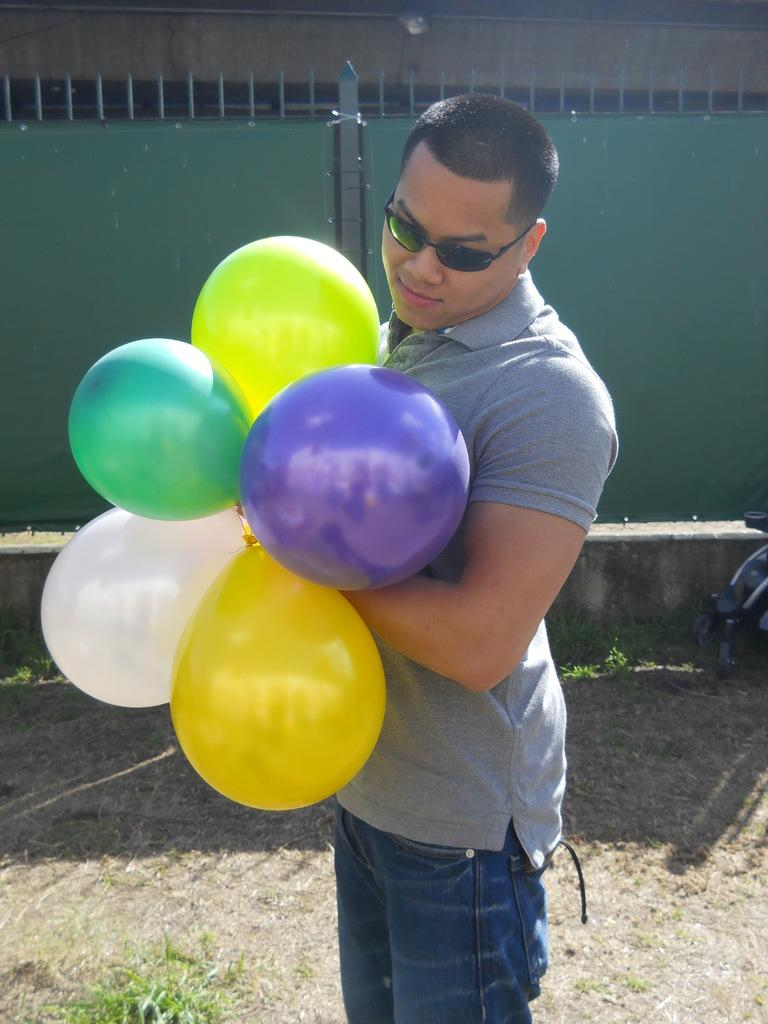What is the main subject of the image? There is a person in the image. Can you describe the person's appearance? The person is wearing spectacles. What is the person holding in the image? The person is holding balloons. What type of effect does the frog have on the sky in the image? There is no frog present in the image, and therefore no such effect can be observed. 